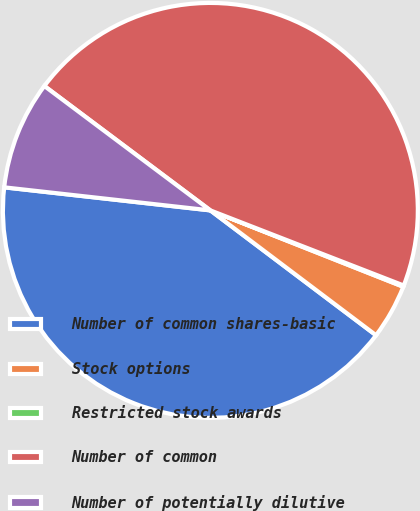Convert chart. <chart><loc_0><loc_0><loc_500><loc_500><pie_chart><fcel>Number of common shares-basic<fcel>Stock options<fcel>Restricted stock awards<fcel>Number of common<fcel>Number of potentially dilutive<nl><fcel>41.49%<fcel>4.28%<fcel>0.1%<fcel>45.66%<fcel>8.46%<nl></chart> 